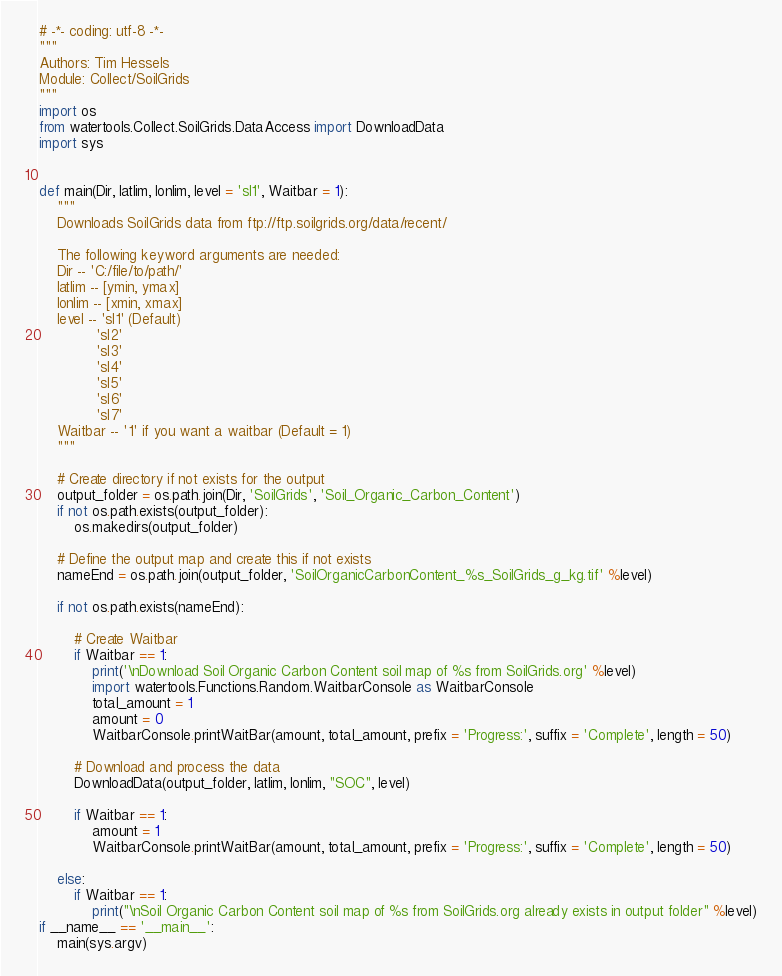<code> <loc_0><loc_0><loc_500><loc_500><_Python_># -*- coding: utf-8 -*-
"""
Authors: Tim Hessels
Module: Collect/SoilGrids
"""
import os
from watertools.Collect.SoilGrids.DataAccess import DownloadData
import sys


def main(Dir, latlim, lonlim, level = 'sl1', Waitbar = 1):
    """
    Downloads SoilGrids data from ftp://ftp.soilgrids.org/data/recent/

    The following keyword arguments are needed:
    Dir -- 'C:/file/to/path/'
    latlim -- [ymin, ymax]
    lonlim -- [xmin, xmax]
    level -- 'sl1' (Default) 
             'sl2'     
             'sl3'     
             'sl4'     
             'sl5'     
             'sl6'     
             'sl7'    
    Waitbar -- '1' if you want a waitbar (Default = 1)
    """

    # Create directory if not exists for the output
    output_folder = os.path.join(Dir, 'SoilGrids', 'Soil_Organic_Carbon_Content')
    if not os.path.exists(output_folder):
        os.makedirs(output_folder)

    # Define the output map and create this if not exists
    nameEnd = os.path.join(output_folder, 'SoilOrganicCarbonContent_%s_SoilGrids_g_kg.tif' %level)    

    if not os.path.exists(nameEnd):

        # Create Waitbar
        if Waitbar == 1:
            print('\nDownload Soil Organic Carbon Content soil map of %s from SoilGrids.org' %level)
            import watertools.Functions.Random.WaitbarConsole as WaitbarConsole
            total_amount = 1
            amount = 0
            WaitbarConsole.printWaitBar(amount, total_amount, prefix = 'Progress:', suffix = 'Complete', length = 50)

        # Download and process the data
        DownloadData(output_folder, latlim, lonlim, "SOC", level)

        if Waitbar == 1:
            amount = 1
            WaitbarConsole.printWaitBar(amount, total_amount, prefix = 'Progress:', suffix = 'Complete', length = 50)

    else:
        if Waitbar == 1:
            print("\nSoil Organic Carbon Content soil map of %s from SoilGrids.org already exists in output folder" %level)
if __name__ == '__main__':
    main(sys.argv)
</code> 